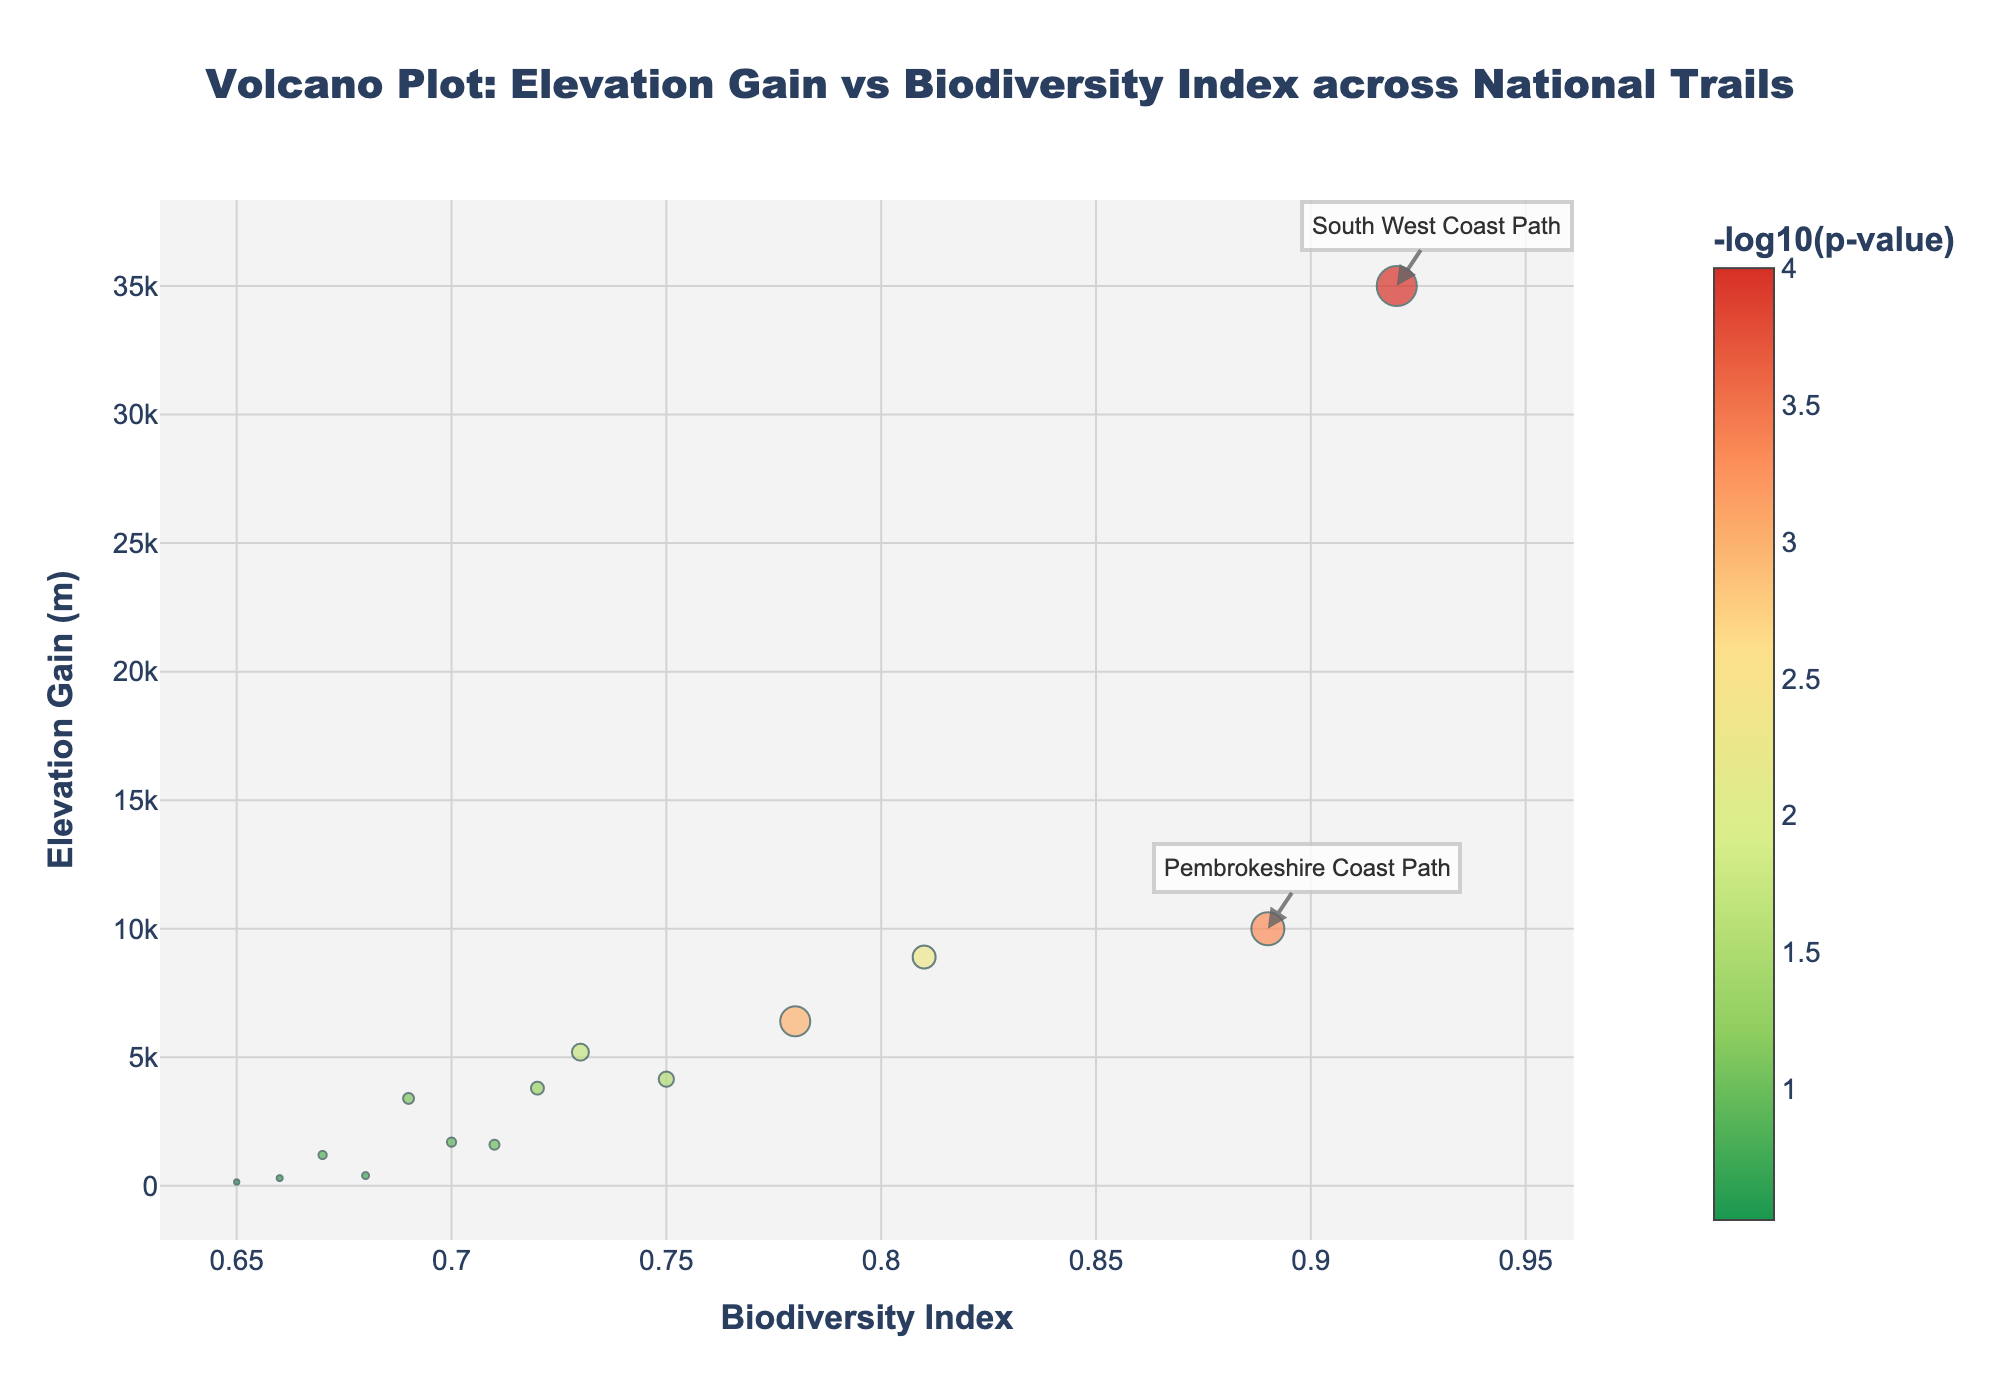What's the title of the plot? The title of the plot is centered at the top in large, bold font.
Answer: Volcano Plot: Elevation Gain vs Biodiversity Index across National Trails How many data points represent the national trails? Count the number of markers (dots) in the plot or refer to the number of entries in the dataset.
Answer: 14 Which trail has the highest elevation gain, and what is its biodiversity index? Locate the marker at the highest point (y-axis) and check its x-axis value and label. The highest marker is annotated.
Answer: South West Coast Path, 0.92 Which trail has the highest biodiversity index, and what is its elevation gain? Find the marker with the highest x-axis value; check its corresponding y-axis value and label. This marker is likely annotated.
Answer: South West Coast Path, 35000 Which trail has the smallest significance value, and what are its elevation gain and biodiversity index? Locate the marker with the highest -log10(p) value (largest marker size). Then check x and y-axis values and label for this marker.
Answer: South West Coast Path, 35000, 0.92 How many trails have a significance value below 0.01? Count the number of markers with a -log10(p) value greater than or equal to 2 (marker size).
Answer: 4 What are the elevation gain and biodiversity index of the trail with the second highest -log10(p) value? Identify the second largest marker (if not already labeled). Locate its values on the x and y-axes.
Answer: Pembrokeshire Coast Path, 10000, 0.89 Compare the elevation gain and biodiversity index between Pennine Way and Offa's Dyke Path. Which trail has a higher biodiversity index? Check the positions of both trail markers on the x-axis. Compare their values.
Answer: Offa's Dyke Path What is the average elevation gain of the trails with a biodiversity index higher than 0.7? Identify trails with x-axis values > 0.7, sum their elevation gains, and divide by the number of trails. These trails are Pennine Way, South West Coast Path, Offa's Dyke Path, Cleveland Way, Hadrian's Wall Path, North Downs Way, South Downs Way, and Pembrokeshire Coast Path. Calculate the average.
Answer: 7763.75 Which trails are annotated on the plot, and why might they be annotated? Identify the trails with labels. They're typically annotated due to extreme values in either elevation gain, biodiversity index, or -log10(p) value.
Answer: South West Coast Path, Pembrokeshire Coast Path, Pennine Way 